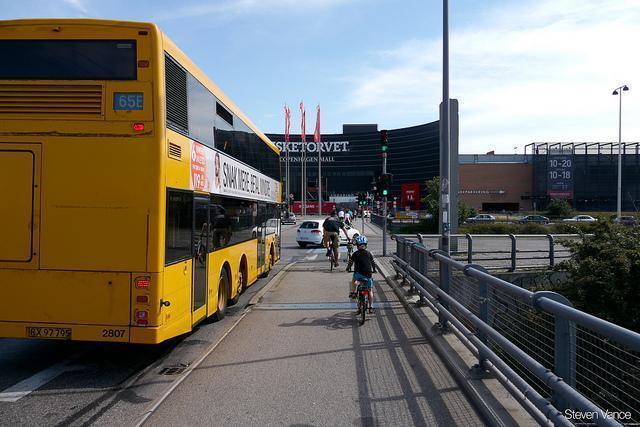What is the full name of the building ahead?
Pick the right solution, then justify: 'Answer: answer
Rationale: rationale.'
Options: Basketorvet, husketorvet, kesketorvet, fisketorvet. Answer: fisketorvet.
Rationale: I did an internet search on copenhagen mall using the portion of the name visible on the building to find the answer. 